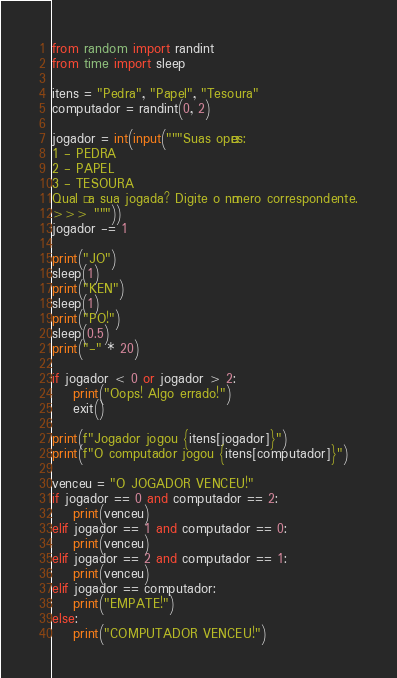Convert code to text. <code><loc_0><loc_0><loc_500><loc_500><_Python_>from random import randint
from time import sleep

itens = "Pedra", "Papel", "Tesoura"
computador = randint(0, 2)

jogador = int(input("""Suas opçôes: 
1 - PEDRA
2 - PAPEL
3 - TESOURA
Qual é a sua jogada? Digite o número correspondente.
>>> """))
jogador -= 1

print("JO")
sleep(1)
print("KEN")
sleep(1)
print("PO!")
sleep(0.5)
print("-" * 20)

if jogador < 0 or jogador > 2:
    print("Oops! Algo errado!")
    exit()

print(f"Jogador jogou {itens[jogador]}")
print(f"O computador jogou {itens[computador]}")

venceu = "O JOGADOR VENCEU!"
if jogador == 0 and computador == 2:
    print(venceu)
elif jogador == 1 and computador == 0:
    print(venceu)
elif jogador == 2 and computador == 1:
    print(venceu)
elif jogador == computador:
    print("EMPATE!")
else:
    print("COMPUTADOR VENCEU!")
</code> 